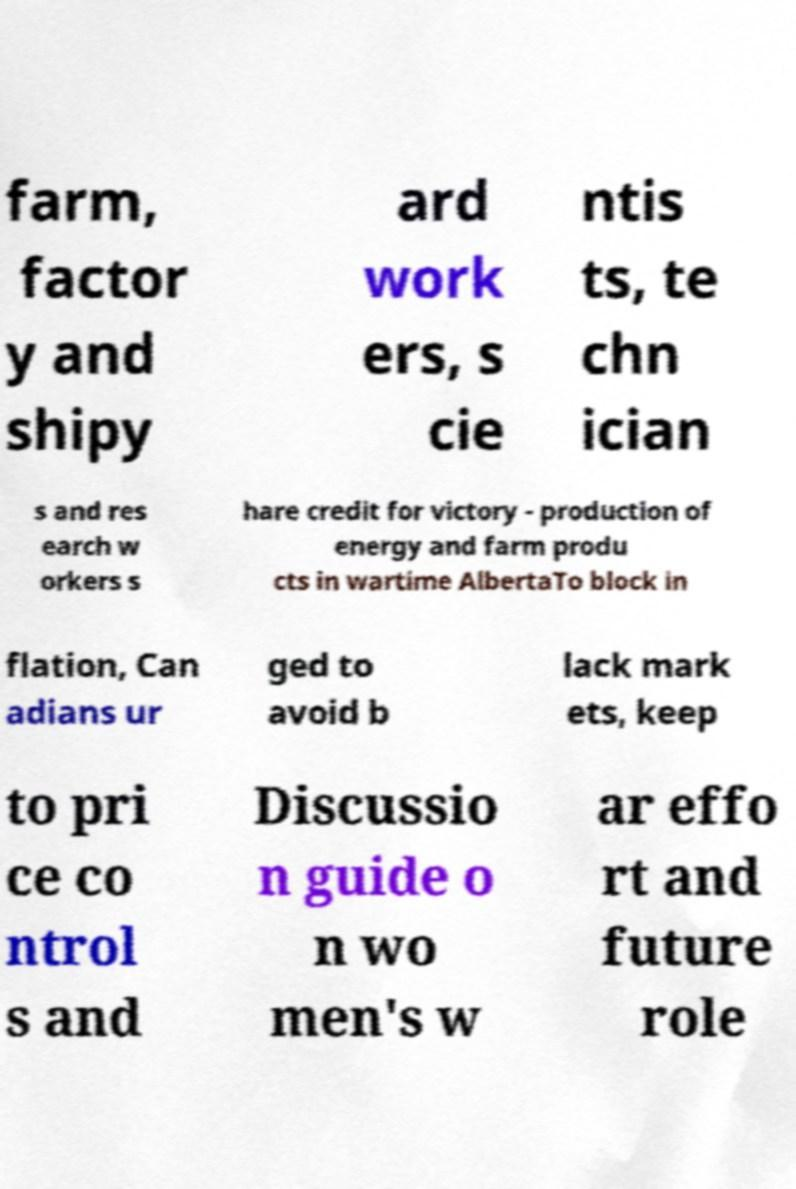There's text embedded in this image that I need extracted. Can you transcribe it verbatim? farm, factor y and shipy ard work ers, s cie ntis ts, te chn ician s and res earch w orkers s hare credit for victory - production of energy and farm produ cts in wartime AlbertaTo block in flation, Can adians ur ged to avoid b lack mark ets, keep to pri ce co ntrol s and Discussio n guide o n wo men's w ar effo rt and future role 